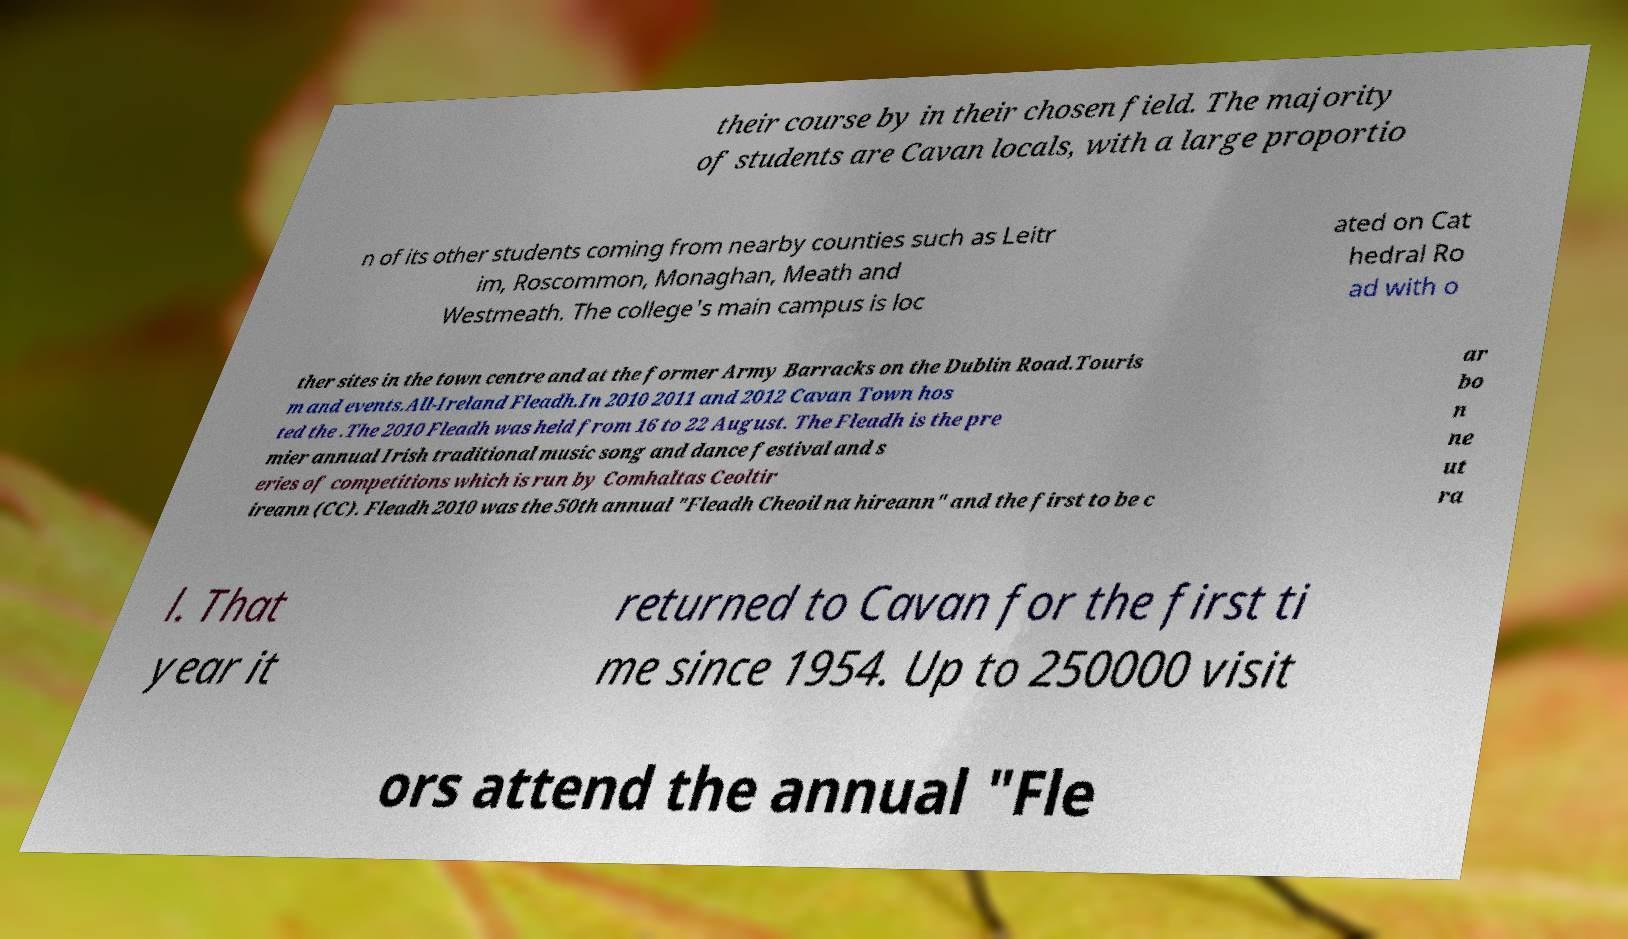For documentation purposes, I need the text within this image transcribed. Could you provide that? their course by in their chosen field. The majority of students are Cavan locals, with a large proportio n of its other students coming from nearby counties such as Leitr im, Roscommon, Monaghan, Meath and Westmeath. The college's main campus is loc ated on Cat hedral Ro ad with o ther sites in the town centre and at the former Army Barracks on the Dublin Road.Touris m and events.All-Ireland Fleadh.In 2010 2011 and 2012 Cavan Town hos ted the .The 2010 Fleadh was held from 16 to 22 August. The Fleadh is the pre mier annual Irish traditional music song and dance festival and s eries of competitions which is run by Comhaltas Ceoltir ireann (CC). Fleadh 2010 was the 50th annual "Fleadh Cheoil na hireann" and the first to be c ar bo n ne ut ra l. That year it returned to Cavan for the first ti me since 1954. Up to 250000 visit ors attend the annual "Fle 